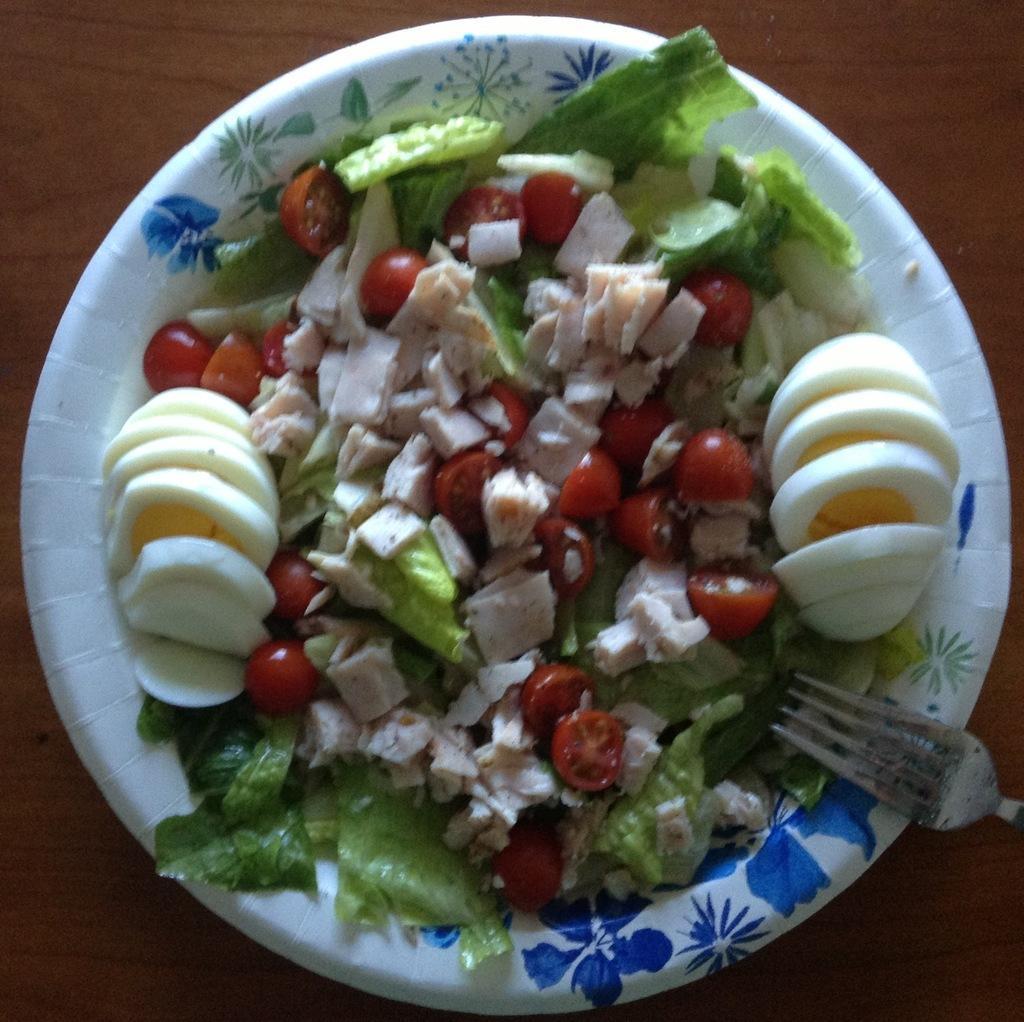Please provide a concise description of this image. In this picture we can see food and a fork in the plate. 